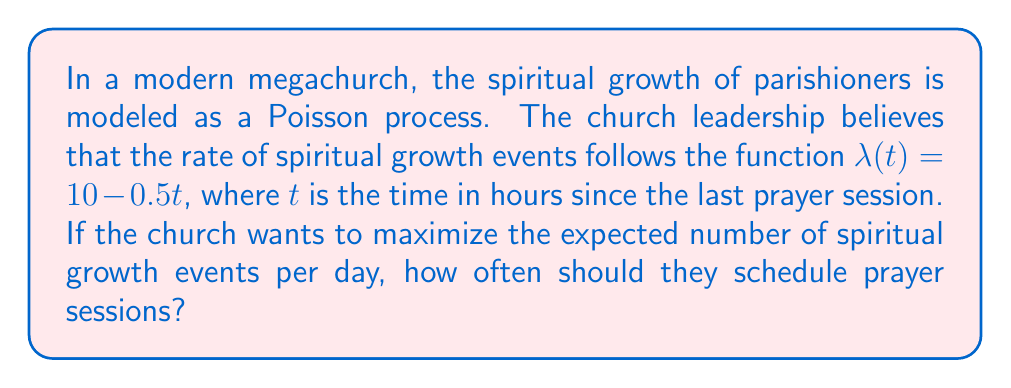Help me with this question. Let's approach this step-by-step:

1) The rate function $\lambda(t) = 10 - 0.5t$ represents the instantaneous rate of spiritual growth events at time $t$ since the last prayer session.

2) To maximize the number of events per day, we need to find the optimal interval between prayer sessions.

3) The expected number of events in an interval $[0, T]$ is given by:

   $$E[N(T)] = \int_0^T \lambda(t) dt$$

4) Substituting our rate function:

   $$E[N(T)] = \int_0^T (10 - 0.5t) dt$$

5) Solving this integral:

   $$E[N(T)] = [10t - 0.25t^2]_0^T = 10T - 0.25T^2$$

6) To find the rate of events per unit time, we divide by T:

   $$\frac{E[N(T)]}{T} = 10 - 0.25T$$

7) To maximize this, we differentiate with respect to T and set to zero:

   $$\frac{d}{dT}(\frac{E[N(T)]}{T}) = -0.25 = 0$$

8) This is always negative, meaning the function is always decreasing. Therefore, the maximum occurs at the smallest possible T.

9) The smallest practical T would be the time it takes to conduct a prayer session. Let's assume this is 1 hour.

10) Therefore, to maximize spiritual growth events, prayer sessions should be held every hour.
Answer: Every hour 